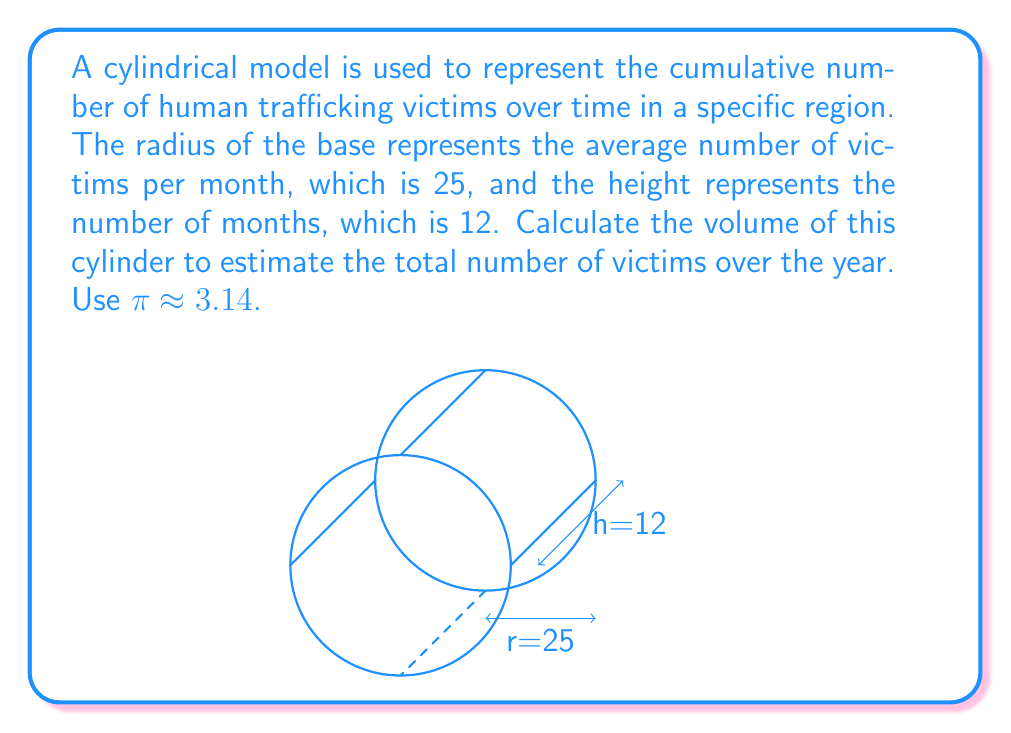What is the answer to this math problem? To solve this problem, we'll use the formula for the volume of a cylinder:

$$V = πr^2h$$

Where:
$V$ = volume of the cylinder
$r$ = radius of the base
$h$ = height of the cylinder

Given:
$r = 25$ (average number of victims per month)
$h = 12$ (number of months)
$π ≈ 3.14$

Step 1: Substitute the values into the formula:
$$V = π(25)^2(12)$$

Step 2: Calculate the square of the radius:
$$V = π(625)(12)$$

Step 3: Multiply the values inside the parentheses:
$$V = π(7500)$$

Step 4: Multiply by π:
$$V = 3.14 * 7500 = 23,550$$

The volume of the cylinder represents the estimated total number of human trafficking victims over the year.
Answer: 23,550 victims 